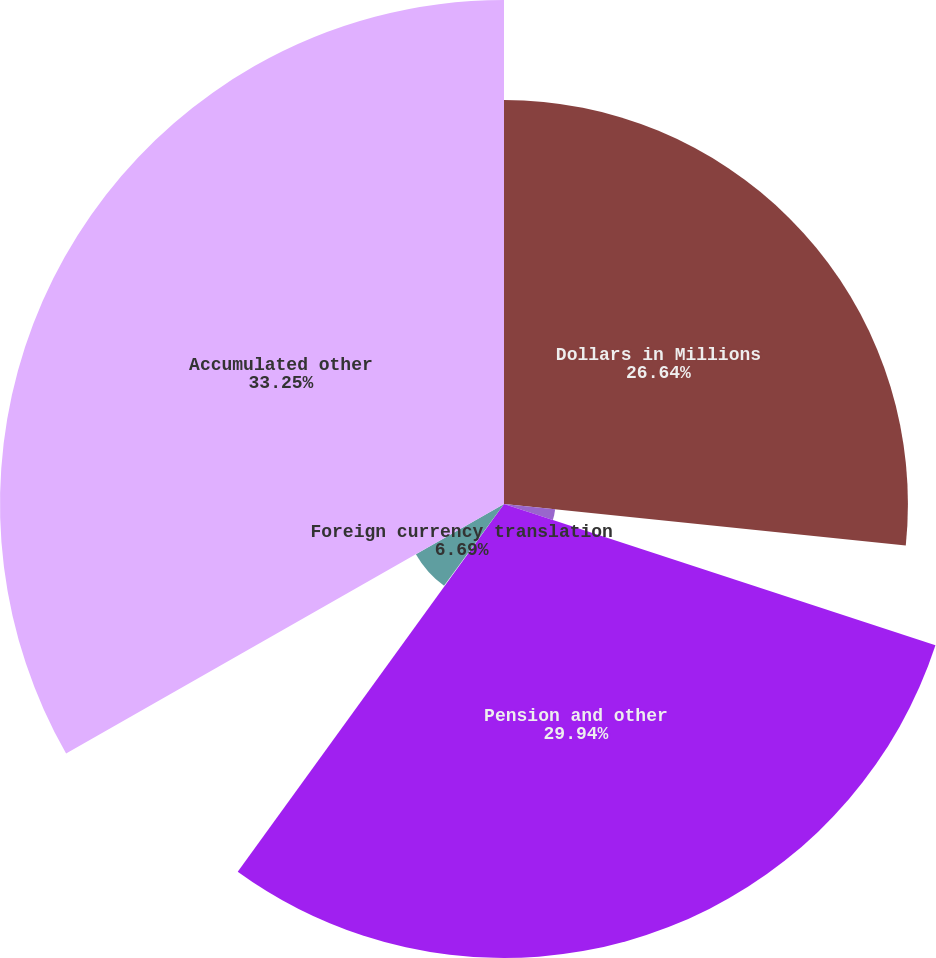Convert chart. <chart><loc_0><loc_0><loc_500><loc_500><pie_chart><fcel>Dollars in Millions<fcel>Derivatives qualifying as cash<fcel>Pension and other<fcel>Available-for-sale securities<fcel>Foreign currency translation<fcel>Accumulated other<nl><fcel>26.64%<fcel>3.39%<fcel>29.94%<fcel>0.09%<fcel>6.69%<fcel>33.24%<nl></chart> 